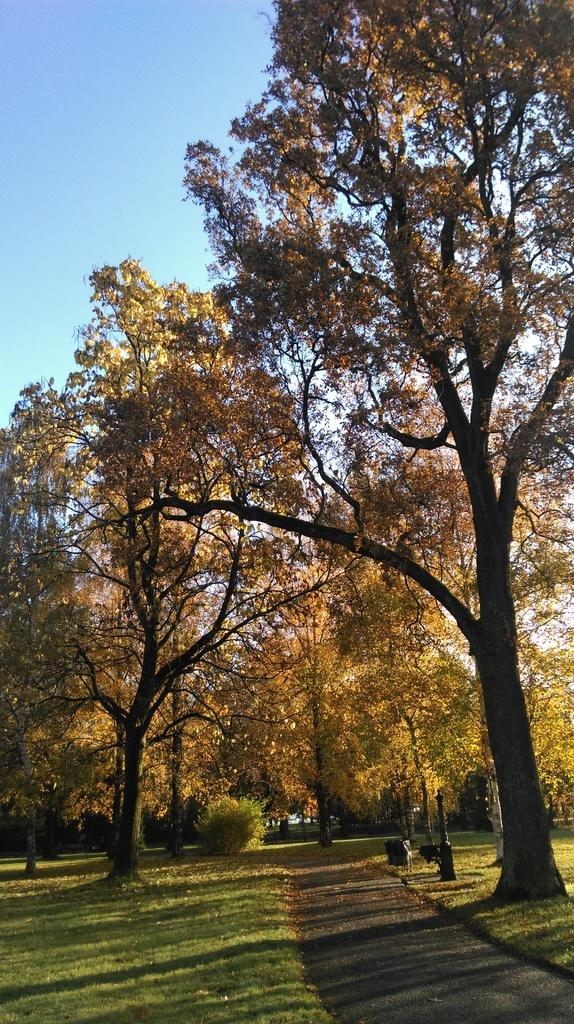What type of vegetation can be seen in the image? There are trees and grass in the image. What other plant is visible in the image? There is a plant in the image. What part of the natural environment is visible in the image? The sky is visible in the image. What type of fog can be seen in the image? There is no fog present in the image; it features trees, grass, a plant, and the sky. 